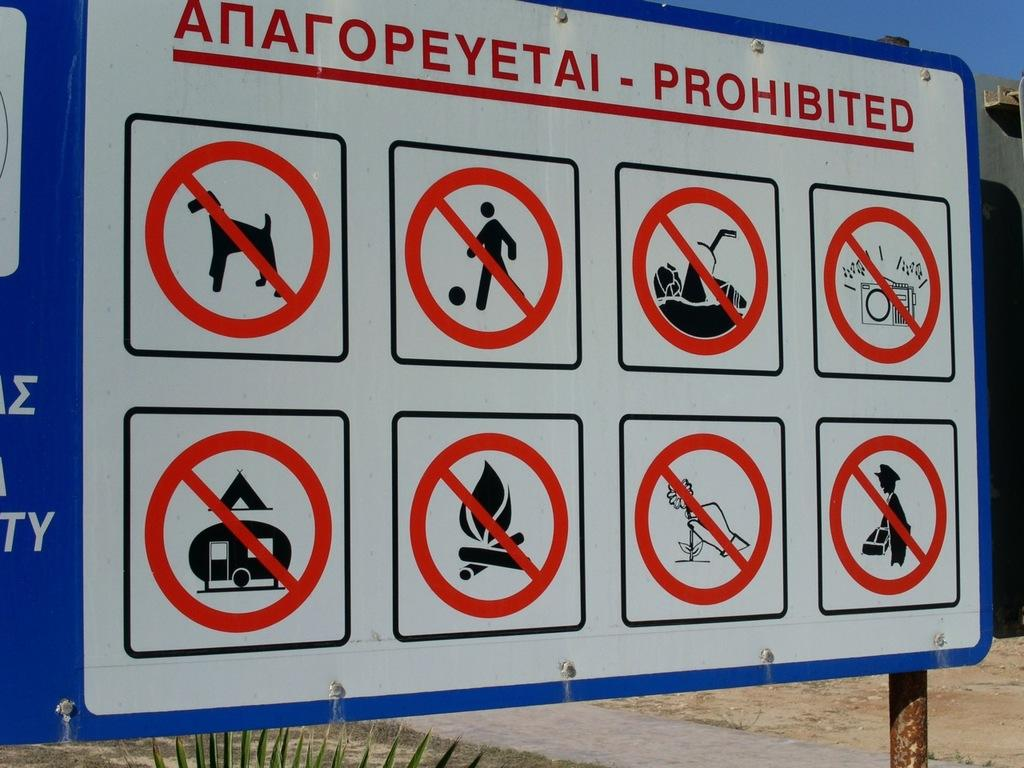<image>
Render a clear and concise summary of the photo. Red and white sign that says "PROHIBITED" near the top. 